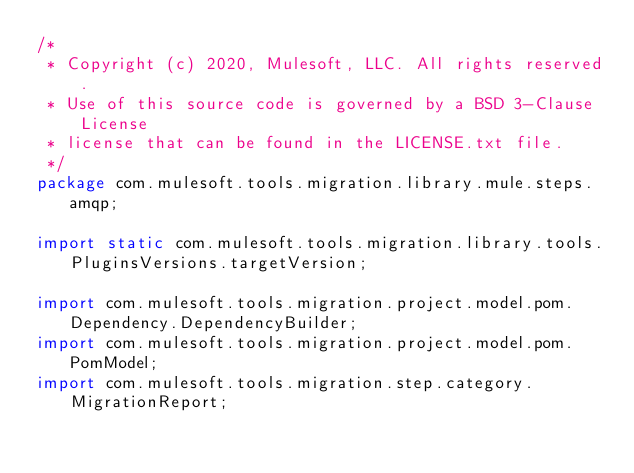<code> <loc_0><loc_0><loc_500><loc_500><_Java_>/*
 * Copyright (c) 2020, Mulesoft, LLC. All rights reserved.
 * Use of this source code is governed by a BSD 3-Clause License
 * license that can be found in the LICENSE.txt file.
 */
package com.mulesoft.tools.migration.library.mule.steps.amqp;

import static com.mulesoft.tools.migration.library.tools.PluginsVersions.targetVersion;

import com.mulesoft.tools.migration.project.model.pom.Dependency.DependencyBuilder;
import com.mulesoft.tools.migration.project.model.pom.PomModel;
import com.mulesoft.tools.migration.step.category.MigrationReport;</code> 